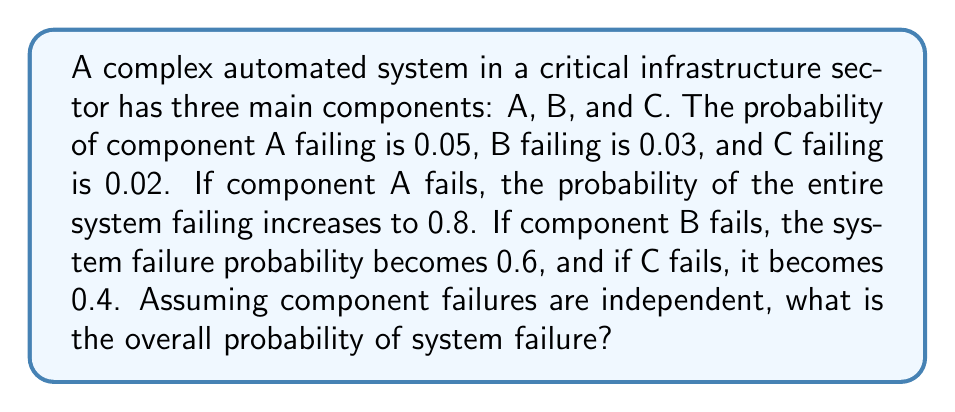Help me with this question. Let's approach this step-by-step using the law of total probability and conditional probability:

1) Define events:
   F: System failure
   A: Component A fails
   B: Component B fails
   C: Component C fails

2) We're given:
   $P(A) = 0.05$, $P(B) = 0.03$, $P(C) = 0.02$
   $P(F|A) = 0.8$, $P(F|B) = 0.6$, $P(F|C) = 0.4$

3) Using the law of total probability:
   $$P(F) = P(F|A)P(A) + P(F|B)P(B) + P(F|C)P(C) + P(F|\overline{A}\cap\overline{B}\cap\overline{C})P(\overline{A}\cap\overline{B}\cap\overline{C})$$

4) We know the first three terms, but need to calculate the last term:
   $P(\overline{A}\cap\overline{B}\cap\overline{C}) = (1-0.05)(1-0.03)(1-0.02) = 0.9031$

5) For $P(F|\overline{A}\cap\overline{B}\cap\overline{C})$, we can assume it's negligibly small, say 0.001, as this represents the probability of system failure when no components fail.

6) Now we can calculate:
   $$P(F) = (0.8)(0.05) + (0.6)(0.03) + (0.4)(0.02) + (0.001)(0.9031)$$
   $$P(F) = 0.04 + 0.018 + 0.008 + 0.0009031$$
   $$P(F) = 0.0669031$$

7) Rounding to four decimal places:
   $$P(F) \approx 0.0669 \text{ or } 6.69\%$$
Answer: 0.0669 or 6.69% 